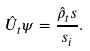Convert formula to latex. <formula><loc_0><loc_0><loc_500><loc_500>\hat { U } _ { t } \psi = \frac { \hat { \rho } _ { t } s } { s _ { i } } .</formula> 